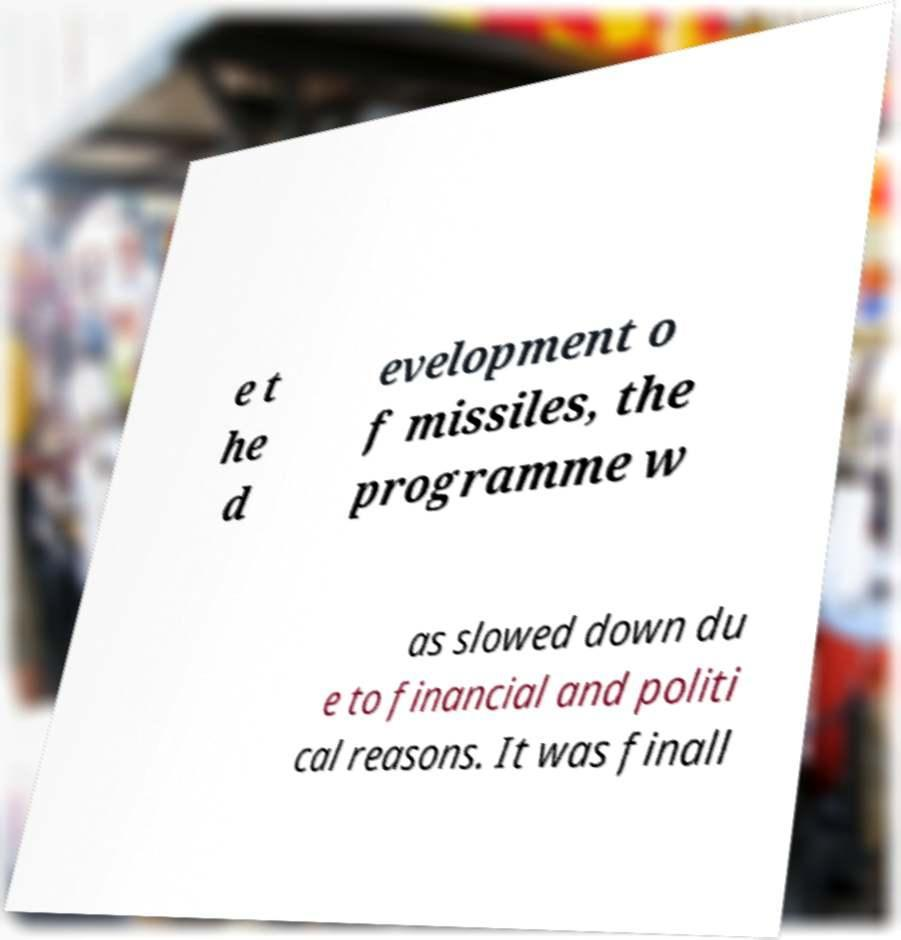Can you read and provide the text displayed in the image?This photo seems to have some interesting text. Can you extract and type it out for me? e t he d evelopment o f missiles, the programme w as slowed down du e to financial and politi cal reasons. It was finall 